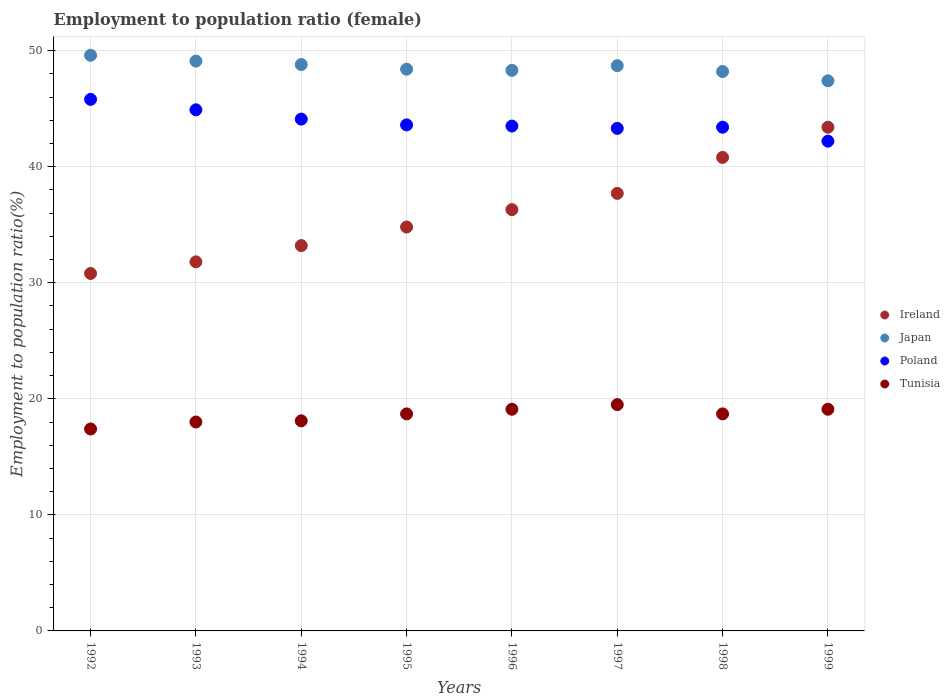How many different coloured dotlines are there?
Your answer should be very brief. 4. What is the employment to population ratio in Tunisia in 1994?
Your answer should be compact. 18.1. Across all years, what is the maximum employment to population ratio in Poland?
Make the answer very short. 45.8. Across all years, what is the minimum employment to population ratio in Tunisia?
Provide a short and direct response. 17.4. In which year was the employment to population ratio in Japan maximum?
Offer a terse response. 1992. What is the total employment to population ratio in Ireland in the graph?
Provide a short and direct response. 288.8. What is the difference between the employment to population ratio in Japan in 1996 and that in 1999?
Your answer should be very brief. 0.9. What is the difference between the employment to population ratio in Ireland in 1993 and the employment to population ratio in Poland in 1995?
Your response must be concise. -11.8. What is the average employment to population ratio in Tunisia per year?
Your answer should be very brief. 18.58. In the year 1997, what is the difference between the employment to population ratio in Tunisia and employment to population ratio in Japan?
Ensure brevity in your answer.  -29.2. In how many years, is the employment to population ratio in Ireland greater than 22 %?
Your response must be concise. 8. What is the ratio of the employment to population ratio in Japan in 1995 to that in 1999?
Your response must be concise. 1.02. What is the difference between the highest and the second highest employment to population ratio in Ireland?
Your response must be concise. 2.6. What is the difference between the highest and the lowest employment to population ratio in Ireland?
Your answer should be very brief. 12.6. Is the employment to population ratio in Japan strictly greater than the employment to population ratio in Poland over the years?
Offer a terse response. Yes. How many dotlines are there?
Provide a short and direct response. 4. How many years are there in the graph?
Your answer should be compact. 8. What is the difference between two consecutive major ticks on the Y-axis?
Keep it short and to the point. 10. Does the graph contain grids?
Make the answer very short. Yes. Where does the legend appear in the graph?
Offer a terse response. Center right. What is the title of the graph?
Offer a terse response. Employment to population ratio (female). Does "Venezuela" appear as one of the legend labels in the graph?
Provide a short and direct response. No. What is the Employment to population ratio(%) in Ireland in 1992?
Your answer should be compact. 30.8. What is the Employment to population ratio(%) in Japan in 1992?
Your answer should be very brief. 49.6. What is the Employment to population ratio(%) of Poland in 1992?
Your answer should be compact. 45.8. What is the Employment to population ratio(%) in Tunisia in 1992?
Give a very brief answer. 17.4. What is the Employment to population ratio(%) in Ireland in 1993?
Provide a succinct answer. 31.8. What is the Employment to population ratio(%) of Japan in 1993?
Your response must be concise. 49.1. What is the Employment to population ratio(%) in Poland in 1993?
Your answer should be compact. 44.9. What is the Employment to population ratio(%) in Ireland in 1994?
Your response must be concise. 33.2. What is the Employment to population ratio(%) in Japan in 1994?
Provide a short and direct response. 48.8. What is the Employment to population ratio(%) of Poland in 1994?
Provide a short and direct response. 44.1. What is the Employment to population ratio(%) in Tunisia in 1994?
Offer a terse response. 18.1. What is the Employment to population ratio(%) in Ireland in 1995?
Provide a short and direct response. 34.8. What is the Employment to population ratio(%) in Japan in 1995?
Offer a terse response. 48.4. What is the Employment to population ratio(%) of Poland in 1995?
Offer a very short reply. 43.6. What is the Employment to population ratio(%) in Tunisia in 1995?
Ensure brevity in your answer.  18.7. What is the Employment to population ratio(%) in Ireland in 1996?
Offer a terse response. 36.3. What is the Employment to population ratio(%) of Japan in 1996?
Your response must be concise. 48.3. What is the Employment to population ratio(%) in Poland in 1996?
Give a very brief answer. 43.5. What is the Employment to population ratio(%) of Tunisia in 1996?
Give a very brief answer. 19.1. What is the Employment to population ratio(%) of Ireland in 1997?
Give a very brief answer. 37.7. What is the Employment to population ratio(%) of Japan in 1997?
Ensure brevity in your answer.  48.7. What is the Employment to population ratio(%) in Poland in 1997?
Give a very brief answer. 43.3. What is the Employment to population ratio(%) in Tunisia in 1997?
Offer a very short reply. 19.5. What is the Employment to population ratio(%) of Ireland in 1998?
Your answer should be compact. 40.8. What is the Employment to population ratio(%) of Japan in 1998?
Provide a short and direct response. 48.2. What is the Employment to population ratio(%) in Poland in 1998?
Give a very brief answer. 43.4. What is the Employment to population ratio(%) in Tunisia in 1998?
Ensure brevity in your answer.  18.7. What is the Employment to population ratio(%) of Ireland in 1999?
Offer a very short reply. 43.4. What is the Employment to population ratio(%) of Japan in 1999?
Provide a succinct answer. 47.4. What is the Employment to population ratio(%) of Poland in 1999?
Your answer should be compact. 42.2. What is the Employment to population ratio(%) of Tunisia in 1999?
Ensure brevity in your answer.  19.1. Across all years, what is the maximum Employment to population ratio(%) of Ireland?
Your answer should be very brief. 43.4. Across all years, what is the maximum Employment to population ratio(%) of Japan?
Provide a succinct answer. 49.6. Across all years, what is the maximum Employment to population ratio(%) of Poland?
Your answer should be very brief. 45.8. Across all years, what is the minimum Employment to population ratio(%) in Ireland?
Give a very brief answer. 30.8. Across all years, what is the minimum Employment to population ratio(%) in Japan?
Provide a short and direct response. 47.4. Across all years, what is the minimum Employment to population ratio(%) of Poland?
Keep it short and to the point. 42.2. Across all years, what is the minimum Employment to population ratio(%) in Tunisia?
Make the answer very short. 17.4. What is the total Employment to population ratio(%) of Ireland in the graph?
Offer a terse response. 288.8. What is the total Employment to population ratio(%) in Japan in the graph?
Make the answer very short. 388.5. What is the total Employment to population ratio(%) in Poland in the graph?
Make the answer very short. 350.8. What is the total Employment to population ratio(%) in Tunisia in the graph?
Your answer should be compact. 148.6. What is the difference between the Employment to population ratio(%) in Ireland in 1992 and that in 1993?
Offer a terse response. -1. What is the difference between the Employment to population ratio(%) in Japan in 1992 and that in 1993?
Your answer should be compact. 0.5. What is the difference between the Employment to population ratio(%) of Japan in 1992 and that in 1994?
Make the answer very short. 0.8. What is the difference between the Employment to population ratio(%) of Poland in 1992 and that in 1994?
Your answer should be very brief. 1.7. What is the difference between the Employment to population ratio(%) of Ireland in 1992 and that in 1995?
Give a very brief answer. -4. What is the difference between the Employment to population ratio(%) in Poland in 1992 and that in 1995?
Your answer should be compact. 2.2. What is the difference between the Employment to population ratio(%) in Ireland in 1992 and that in 1996?
Your answer should be compact. -5.5. What is the difference between the Employment to population ratio(%) of Ireland in 1992 and that in 1997?
Your response must be concise. -6.9. What is the difference between the Employment to population ratio(%) in Japan in 1992 and that in 1997?
Provide a succinct answer. 0.9. What is the difference between the Employment to population ratio(%) in Poland in 1992 and that in 1997?
Provide a short and direct response. 2.5. What is the difference between the Employment to population ratio(%) in Japan in 1992 and that in 1998?
Your answer should be compact. 1.4. What is the difference between the Employment to population ratio(%) in Poland in 1992 and that in 1998?
Make the answer very short. 2.4. What is the difference between the Employment to population ratio(%) in Tunisia in 1992 and that in 1998?
Make the answer very short. -1.3. What is the difference between the Employment to population ratio(%) of Poland in 1992 and that in 1999?
Keep it short and to the point. 3.6. What is the difference between the Employment to population ratio(%) of Tunisia in 1993 and that in 1994?
Your response must be concise. -0.1. What is the difference between the Employment to population ratio(%) of Ireland in 1993 and that in 1995?
Offer a very short reply. -3. What is the difference between the Employment to population ratio(%) of Tunisia in 1993 and that in 1995?
Your answer should be very brief. -0.7. What is the difference between the Employment to population ratio(%) of Ireland in 1993 and that in 1996?
Ensure brevity in your answer.  -4.5. What is the difference between the Employment to population ratio(%) in Japan in 1993 and that in 1997?
Offer a very short reply. 0.4. What is the difference between the Employment to population ratio(%) in Japan in 1993 and that in 1998?
Offer a terse response. 0.9. What is the difference between the Employment to population ratio(%) in Tunisia in 1993 and that in 1998?
Offer a terse response. -0.7. What is the difference between the Employment to population ratio(%) of Japan in 1993 and that in 1999?
Keep it short and to the point. 1.7. What is the difference between the Employment to population ratio(%) in Poland in 1993 and that in 1999?
Your answer should be compact. 2.7. What is the difference between the Employment to population ratio(%) in Japan in 1994 and that in 1995?
Your response must be concise. 0.4. What is the difference between the Employment to population ratio(%) in Tunisia in 1994 and that in 1995?
Offer a terse response. -0.6. What is the difference between the Employment to population ratio(%) of Ireland in 1994 and that in 1996?
Provide a succinct answer. -3.1. What is the difference between the Employment to population ratio(%) of Japan in 1994 and that in 1996?
Your answer should be compact. 0.5. What is the difference between the Employment to population ratio(%) in Poland in 1994 and that in 1996?
Your answer should be compact. 0.6. What is the difference between the Employment to population ratio(%) in Tunisia in 1994 and that in 1996?
Your response must be concise. -1. What is the difference between the Employment to population ratio(%) of Ireland in 1994 and that in 1997?
Provide a succinct answer. -4.5. What is the difference between the Employment to population ratio(%) in Japan in 1994 and that in 1997?
Make the answer very short. 0.1. What is the difference between the Employment to population ratio(%) in Tunisia in 1994 and that in 1997?
Provide a short and direct response. -1.4. What is the difference between the Employment to population ratio(%) in Poland in 1994 and that in 1998?
Ensure brevity in your answer.  0.7. What is the difference between the Employment to population ratio(%) in Poland in 1994 and that in 1999?
Your answer should be compact. 1.9. What is the difference between the Employment to population ratio(%) of Japan in 1995 and that in 1996?
Ensure brevity in your answer.  0.1. What is the difference between the Employment to population ratio(%) of Ireland in 1995 and that in 1997?
Your answer should be very brief. -2.9. What is the difference between the Employment to population ratio(%) of Poland in 1995 and that in 1997?
Ensure brevity in your answer.  0.3. What is the difference between the Employment to population ratio(%) in Japan in 1995 and that in 1998?
Provide a succinct answer. 0.2. What is the difference between the Employment to population ratio(%) of Japan in 1995 and that in 1999?
Keep it short and to the point. 1. What is the difference between the Employment to population ratio(%) in Poland in 1995 and that in 1999?
Offer a terse response. 1.4. What is the difference between the Employment to population ratio(%) in Tunisia in 1995 and that in 1999?
Provide a short and direct response. -0.4. What is the difference between the Employment to population ratio(%) of Tunisia in 1996 and that in 1997?
Provide a short and direct response. -0.4. What is the difference between the Employment to population ratio(%) in Ireland in 1996 and that in 1998?
Your response must be concise. -4.5. What is the difference between the Employment to population ratio(%) of Tunisia in 1996 and that in 1998?
Your response must be concise. 0.4. What is the difference between the Employment to population ratio(%) of Tunisia in 1996 and that in 1999?
Keep it short and to the point. 0. What is the difference between the Employment to population ratio(%) in Ireland in 1997 and that in 1998?
Ensure brevity in your answer.  -3.1. What is the difference between the Employment to population ratio(%) of Poland in 1997 and that in 1998?
Give a very brief answer. -0.1. What is the difference between the Employment to population ratio(%) in Ireland in 1997 and that in 1999?
Make the answer very short. -5.7. What is the difference between the Employment to population ratio(%) in Japan in 1997 and that in 1999?
Offer a very short reply. 1.3. What is the difference between the Employment to population ratio(%) of Ireland in 1998 and that in 1999?
Make the answer very short. -2.6. What is the difference between the Employment to population ratio(%) of Tunisia in 1998 and that in 1999?
Your response must be concise. -0.4. What is the difference between the Employment to population ratio(%) of Ireland in 1992 and the Employment to population ratio(%) of Japan in 1993?
Your response must be concise. -18.3. What is the difference between the Employment to population ratio(%) of Ireland in 1992 and the Employment to population ratio(%) of Poland in 1993?
Your answer should be compact. -14.1. What is the difference between the Employment to population ratio(%) of Ireland in 1992 and the Employment to population ratio(%) of Tunisia in 1993?
Your answer should be very brief. 12.8. What is the difference between the Employment to population ratio(%) in Japan in 1992 and the Employment to population ratio(%) in Poland in 1993?
Offer a terse response. 4.7. What is the difference between the Employment to population ratio(%) of Japan in 1992 and the Employment to population ratio(%) of Tunisia in 1993?
Provide a succinct answer. 31.6. What is the difference between the Employment to population ratio(%) of Poland in 1992 and the Employment to population ratio(%) of Tunisia in 1993?
Provide a succinct answer. 27.8. What is the difference between the Employment to population ratio(%) of Ireland in 1992 and the Employment to population ratio(%) of Japan in 1994?
Ensure brevity in your answer.  -18. What is the difference between the Employment to population ratio(%) in Japan in 1992 and the Employment to population ratio(%) in Poland in 1994?
Provide a short and direct response. 5.5. What is the difference between the Employment to population ratio(%) in Japan in 1992 and the Employment to population ratio(%) in Tunisia in 1994?
Give a very brief answer. 31.5. What is the difference between the Employment to population ratio(%) in Poland in 1992 and the Employment to population ratio(%) in Tunisia in 1994?
Offer a very short reply. 27.7. What is the difference between the Employment to population ratio(%) of Ireland in 1992 and the Employment to population ratio(%) of Japan in 1995?
Keep it short and to the point. -17.6. What is the difference between the Employment to population ratio(%) of Ireland in 1992 and the Employment to population ratio(%) of Poland in 1995?
Keep it short and to the point. -12.8. What is the difference between the Employment to population ratio(%) of Ireland in 1992 and the Employment to population ratio(%) of Tunisia in 1995?
Your answer should be compact. 12.1. What is the difference between the Employment to population ratio(%) in Japan in 1992 and the Employment to population ratio(%) in Tunisia in 1995?
Provide a short and direct response. 30.9. What is the difference between the Employment to population ratio(%) of Poland in 1992 and the Employment to population ratio(%) of Tunisia in 1995?
Offer a very short reply. 27.1. What is the difference between the Employment to population ratio(%) in Ireland in 1992 and the Employment to population ratio(%) in Japan in 1996?
Ensure brevity in your answer.  -17.5. What is the difference between the Employment to population ratio(%) in Ireland in 1992 and the Employment to population ratio(%) in Poland in 1996?
Ensure brevity in your answer.  -12.7. What is the difference between the Employment to population ratio(%) in Japan in 1992 and the Employment to population ratio(%) in Poland in 1996?
Keep it short and to the point. 6.1. What is the difference between the Employment to population ratio(%) of Japan in 1992 and the Employment to population ratio(%) of Tunisia in 1996?
Keep it short and to the point. 30.5. What is the difference between the Employment to population ratio(%) of Poland in 1992 and the Employment to population ratio(%) of Tunisia in 1996?
Provide a short and direct response. 26.7. What is the difference between the Employment to population ratio(%) in Ireland in 1992 and the Employment to population ratio(%) in Japan in 1997?
Your answer should be compact. -17.9. What is the difference between the Employment to population ratio(%) in Japan in 1992 and the Employment to population ratio(%) in Tunisia in 1997?
Make the answer very short. 30.1. What is the difference between the Employment to population ratio(%) in Poland in 1992 and the Employment to population ratio(%) in Tunisia in 1997?
Your answer should be very brief. 26.3. What is the difference between the Employment to population ratio(%) in Ireland in 1992 and the Employment to population ratio(%) in Japan in 1998?
Ensure brevity in your answer.  -17.4. What is the difference between the Employment to population ratio(%) in Ireland in 1992 and the Employment to population ratio(%) in Tunisia in 1998?
Provide a short and direct response. 12.1. What is the difference between the Employment to population ratio(%) in Japan in 1992 and the Employment to population ratio(%) in Tunisia in 1998?
Offer a terse response. 30.9. What is the difference between the Employment to population ratio(%) of Poland in 1992 and the Employment to population ratio(%) of Tunisia in 1998?
Give a very brief answer. 27.1. What is the difference between the Employment to population ratio(%) of Ireland in 1992 and the Employment to population ratio(%) of Japan in 1999?
Your answer should be very brief. -16.6. What is the difference between the Employment to population ratio(%) of Japan in 1992 and the Employment to population ratio(%) of Poland in 1999?
Make the answer very short. 7.4. What is the difference between the Employment to population ratio(%) of Japan in 1992 and the Employment to population ratio(%) of Tunisia in 1999?
Offer a terse response. 30.5. What is the difference between the Employment to population ratio(%) of Poland in 1992 and the Employment to population ratio(%) of Tunisia in 1999?
Your answer should be very brief. 26.7. What is the difference between the Employment to population ratio(%) of Ireland in 1993 and the Employment to population ratio(%) of Japan in 1994?
Make the answer very short. -17. What is the difference between the Employment to population ratio(%) of Ireland in 1993 and the Employment to population ratio(%) of Poland in 1994?
Keep it short and to the point. -12.3. What is the difference between the Employment to population ratio(%) in Ireland in 1993 and the Employment to population ratio(%) in Tunisia in 1994?
Keep it short and to the point. 13.7. What is the difference between the Employment to population ratio(%) in Japan in 1993 and the Employment to population ratio(%) in Tunisia in 1994?
Your response must be concise. 31. What is the difference between the Employment to population ratio(%) of Poland in 1993 and the Employment to population ratio(%) of Tunisia in 1994?
Offer a very short reply. 26.8. What is the difference between the Employment to population ratio(%) in Ireland in 1993 and the Employment to population ratio(%) in Japan in 1995?
Your answer should be compact. -16.6. What is the difference between the Employment to population ratio(%) of Japan in 1993 and the Employment to population ratio(%) of Poland in 1995?
Keep it short and to the point. 5.5. What is the difference between the Employment to population ratio(%) of Japan in 1993 and the Employment to population ratio(%) of Tunisia in 1995?
Offer a terse response. 30.4. What is the difference between the Employment to population ratio(%) in Poland in 1993 and the Employment to population ratio(%) in Tunisia in 1995?
Offer a very short reply. 26.2. What is the difference between the Employment to population ratio(%) of Ireland in 1993 and the Employment to population ratio(%) of Japan in 1996?
Ensure brevity in your answer.  -16.5. What is the difference between the Employment to population ratio(%) of Ireland in 1993 and the Employment to population ratio(%) of Poland in 1996?
Keep it short and to the point. -11.7. What is the difference between the Employment to population ratio(%) of Japan in 1993 and the Employment to population ratio(%) of Tunisia in 1996?
Make the answer very short. 30. What is the difference between the Employment to population ratio(%) of Poland in 1993 and the Employment to population ratio(%) of Tunisia in 1996?
Offer a terse response. 25.8. What is the difference between the Employment to population ratio(%) of Ireland in 1993 and the Employment to population ratio(%) of Japan in 1997?
Your response must be concise. -16.9. What is the difference between the Employment to population ratio(%) of Ireland in 1993 and the Employment to population ratio(%) of Tunisia in 1997?
Give a very brief answer. 12.3. What is the difference between the Employment to population ratio(%) of Japan in 1993 and the Employment to population ratio(%) of Tunisia in 1997?
Your response must be concise. 29.6. What is the difference between the Employment to population ratio(%) in Poland in 1993 and the Employment to population ratio(%) in Tunisia in 1997?
Your answer should be very brief. 25.4. What is the difference between the Employment to population ratio(%) in Ireland in 1993 and the Employment to population ratio(%) in Japan in 1998?
Offer a very short reply. -16.4. What is the difference between the Employment to population ratio(%) in Ireland in 1993 and the Employment to population ratio(%) in Tunisia in 1998?
Your response must be concise. 13.1. What is the difference between the Employment to population ratio(%) of Japan in 1993 and the Employment to population ratio(%) of Poland in 1998?
Your answer should be compact. 5.7. What is the difference between the Employment to population ratio(%) of Japan in 1993 and the Employment to population ratio(%) of Tunisia in 1998?
Provide a succinct answer. 30.4. What is the difference between the Employment to population ratio(%) of Poland in 1993 and the Employment to population ratio(%) of Tunisia in 1998?
Ensure brevity in your answer.  26.2. What is the difference between the Employment to population ratio(%) of Ireland in 1993 and the Employment to population ratio(%) of Japan in 1999?
Provide a short and direct response. -15.6. What is the difference between the Employment to population ratio(%) in Japan in 1993 and the Employment to population ratio(%) in Tunisia in 1999?
Your response must be concise. 30. What is the difference between the Employment to population ratio(%) in Poland in 1993 and the Employment to population ratio(%) in Tunisia in 1999?
Provide a short and direct response. 25.8. What is the difference between the Employment to population ratio(%) of Ireland in 1994 and the Employment to population ratio(%) of Japan in 1995?
Your answer should be very brief. -15.2. What is the difference between the Employment to population ratio(%) of Ireland in 1994 and the Employment to population ratio(%) of Poland in 1995?
Give a very brief answer. -10.4. What is the difference between the Employment to population ratio(%) of Japan in 1994 and the Employment to population ratio(%) of Tunisia in 1995?
Your answer should be compact. 30.1. What is the difference between the Employment to population ratio(%) in Poland in 1994 and the Employment to population ratio(%) in Tunisia in 1995?
Your answer should be compact. 25.4. What is the difference between the Employment to population ratio(%) in Ireland in 1994 and the Employment to population ratio(%) in Japan in 1996?
Make the answer very short. -15.1. What is the difference between the Employment to population ratio(%) in Ireland in 1994 and the Employment to population ratio(%) in Poland in 1996?
Keep it short and to the point. -10.3. What is the difference between the Employment to population ratio(%) in Ireland in 1994 and the Employment to population ratio(%) in Tunisia in 1996?
Offer a very short reply. 14.1. What is the difference between the Employment to population ratio(%) of Japan in 1994 and the Employment to population ratio(%) of Poland in 1996?
Your answer should be compact. 5.3. What is the difference between the Employment to population ratio(%) in Japan in 1994 and the Employment to population ratio(%) in Tunisia in 1996?
Keep it short and to the point. 29.7. What is the difference between the Employment to population ratio(%) in Poland in 1994 and the Employment to population ratio(%) in Tunisia in 1996?
Make the answer very short. 25. What is the difference between the Employment to population ratio(%) in Ireland in 1994 and the Employment to population ratio(%) in Japan in 1997?
Give a very brief answer. -15.5. What is the difference between the Employment to population ratio(%) in Ireland in 1994 and the Employment to population ratio(%) in Tunisia in 1997?
Your answer should be very brief. 13.7. What is the difference between the Employment to population ratio(%) in Japan in 1994 and the Employment to population ratio(%) in Poland in 1997?
Ensure brevity in your answer.  5.5. What is the difference between the Employment to population ratio(%) of Japan in 1994 and the Employment to population ratio(%) of Tunisia in 1997?
Ensure brevity in your answer.  29.3. What is the difference between the Employment to population ratio(%) in Poland in 1994 and the Employment to population ratio(%) in Tunisia in 1997?
Provide a succinct answer. 24.6. What is the difference between the Employment to population ratio(%) of Japan in 1994 and the Employment to population ratio(%) of Tunisia in 1998?
Ensure brevity in your answer.  30.1. What is the difference between the Employment to population ratio(%) of Poland in 1994 and the Employment to population ratio(%) of Tunisia in 1998?
Give a very brief answer. 25.4. What is the difference between the Employment to population ratio(%) in Ireland in 1994 and the Employment to population ratio(%) in Japan in 1999?
Offer a terse response. -14.2. What is the difference between the Employment to population ratio(%) in Ireland in 1994 and the Employment to population ratio(%) in Tunisia in 1999?
Keep it short and to the point. 14.1. What is the difference between the Employment to population ratio(%) in Japan in 1994 and the Employment to population ratio(%) in Tunisia in 1999?
Your answer should be compact. 29.7. What is the difference between the Employment to population ratio(%) in Poland in 1994 and the Employment to population ratio(%) in Tunisia in 1999?
Keep it short and to the point. 25. What is the difference between the Employment to population ratio(%) of Japan in 1995 and the Employment to population ratio(%) of Tunisia in 1996?
Keep it short and to the point. 29.3. What is the difference between the Employment to population ratio(%) of Poland in 1995 and the Employment to population ratio(%) of Tunisia in 1996?
Make the answer very short. 24.5. What is the difference between the Employment to population ratio(%) in Ireland in 1995 and the Employment to population ratio(%) in Japan in 1997?
Give a very brief answer. -13.9. What is the difference between the Employment to population ratio(%) in Ireland in 1995 and the Employment to population ratio(%) in Poland in 1997?
Your answer should be compact. -8.5. What is the difference between the Employment to population ratio(%) in Ireland in 1995 and the Employment to population ratio(%) in Tunisia in 1997?
Offer a terse response. 15.3. What is the difference between the Employment to population ratio(%) of Japan in 1995 and the Employment to population ratio(%) of Tunisia in 1997?
Provide a succinct answer. 28.9. What is the difference between the Employment to population ratio(%) in Poland in 1995 and the Employment to population ratio(%) in Tunisia in 1997?
Provide a succinct answer. 24.1. What is the difference between the Employment to population ratio(%) of Ireland in 1995 and the Employment to population ratio(%) of Japan in 1998?
Your response must be concise. -13.4. What is the difference between the Employment to population ratio(%) of Japan in 1995 and the Employment to population ratio(%) of Tunisia in 1998?
Provide a succinct answer. 29.7. What is the difference between the Employment to population ratio(%) of Poland in 1995 and the Employment to population ratio(%) of Tunisia in 1998?
Make the answer very short. 24.9. What is the difference between the Employment to population ratio(%) of Japan in 1995 and the Employment to population ratio(%) of Poland in 1999?
Give a very brief answer. 6.2. What is the difference between the Employment to population ratio(%) of Japan in 1995 and the Employment to population ratio(%) of Tunisia in 1999?
Your answer should be very brief. 29.3. What is the difference between the Employment to population ratio(%) of Ireland in 1996 and the Employment to population ratio(%) of Japan in 1997?
Offer a terse response. -12.4. What is the difference between the Employment to population ratio(%) of Ireland in 1996 and the Employment to population ratio(%) of Poland in 1997?
Your response must be concise. -7. What is the difference between the Employment to population ratio(%) of Ireland in 1996 and the Employment to population ratio(%) of Tunisia in 1997?
Make the answer very short. 16.8. What is the difference between the Employment to population ratio(%) of Japan in 1996 and the Employment to population ratio(%) of Tunisia in 1997?
Your response must be concise. 28.8. What is the difference between the Employment to population ratio(%) of Ireland in 1996 and the Employment to population ratio(%) of Poland in 1998?
Provide a succinct answer. -7.1. What is the difference between the Employment to population ratio(%) in Japan in 1996 and the Employment to population ratio(%) in Poland in 1998?
Your answer should be compact. 4.9. What is the difference between the Employment to population ratio(%) in Japan in 1996 and the Employment to population ratio(%) in Tunisia in 1998?
Offer a terse response. 29.6. What is the difference between the Employment to population ratio(%) in Poland in 1996 and the Employment to population ratio(%) in Tunisia in 1998?
Provide a succinct answer. 24.8. What is the difference between the Employment to population ratio(%) in Ireland in 1996 and the Employment to population ratio(%) in Tunisia in 1999?
Your response must be concise. 17.2. What is the difference between the Employment to population ratio(%) in Japan in 1996 and the Employment to population ratio(%) in Poland in 1999?
Your answer should be compact. 6.1. What is the difference between the Employment to population ratio(%) of Japan in 1996 and the Employment to population ratio(%) of Tunisia in 1999?
Your answer should be very brief. 29.2. What is the difference between the Employment to population ratio(%) of Poland in 1996 and the Employment to population ratio(%) of Tunisia in 1999?
Make the answer very short. 24.4. What is the difference between the Employment to population ratio(%) of Ireland in 1997 and the Employment to population ratio(%) of Poland in 1998?
Make the answer very short. -5.7. What is the difference between the Employment to population ratio(%) in Japan in 1997 and the Employment to population ratio(%) in Tunisia in 1998?
Your answer should be very brief. 30. What is the difference between the Employment to population ratio(%) in Poland in 1997 and the Employment to population ratio(%) in Tunisia in 1998?
Provide a short and direct response. 24.6. What is the difference between the Employment to population ratio(%) in Japan in 1997 and the Employment to population ratio(%) in Poland in 1999?
Ensure brevity in your answer.  6.5. What is the difference between the Employment to population ratio(%) in Japan in 1997 and the Employment to population ratio(%) in Tunisia in 1999?
Give a very brief answer. 29.6. What is the difference between the Employment to population ratio(%) in Poland in 1997 and the Employment to population ratio(%) in Tunisia in 1999?
Provide a short and direct response. 24.2. What is the difference between the Employment to population ratio(%) in Ireland in 1998 and the Employment to population ratio(%) in Japan in 1999?
Keep it short and to the point. -6.6. What is the difference between the Employment to population ratio(%) in Ireland in 1998 and the Employment to population ratio(%) in Tunisia in 1999?
Give a very brief answer. 21.7. What is the difference between the Employment to population ratio(%) of Japan in 1998 and the Employment to population ratio(%) of Tunisia in 1999?
Offer a very short reply. 29.1. What is the difference between the Employment to population ratio(%) of Poland in 1998 and the Employment to population ratio(%) of Tunisia in 1999?
Keep it short and to the point. 24.3. What is the average Employment to population ratio(%) of Ireland per year?
Keep it short and to the point. 36.1. What is the average Employment to population ratio(%) of Japan per year?
Ensure brevity in your answer.  48.56. What is the average Employment to population ratio(%) in Poland per year?
Give a very brief answer. 43.85. What is the average Employment to population ratio(%) of Tunisia per year?
Ensure brevity in your answer.  18.57. In the year 1992, what is the difference between the Employment to population ratio(%) of Ireland and Employment to population ratio(%) of Japan?
Give a very brief answer. -18.8. In the year 1992, what is the difference between the Employment to population ratio(%) of Ireland and Employment to population ratio(%) of Poland?
Offer a very short reply. -15. In the year 1992, what is the difference between the Employment to population ratio(%) in Japan and Employment to population ratio(%) in Tunisia?
Your response must be concise. 32.2. In the year 1992, what is the difference between the Employment to population ratio(%) in Poland and Employment to population ratio(%) in Tunisia?
Offer a terse response. 28.4. In the year 1993, what is the difference between the Employment to population ratio(%) of Ireland and Employment to population ratio(%) of Japan?
Give a very brief answer. -17.3. In the year 1993, what is the difference between the Employment to population ratio(%) of Ireland and Employment to population ratio(%) of Poland?
Give a very brief answer. -13.1. In the year 1993, what is the difference between the Employment to population ratio(%) in Ireland and Employment to population ratio(%) in Tunisia?
Your answer should be compact. 13.8. In the year 1993, what is the difference between the Employment to population ratio(%) of Japan and Employment to population ratio(%) of Tunisia?
Your answer should be very brief. 31.1. In the year 1993, what is the difference between the Employment to population ratio(%) in Poland and Employment to population ratio(%) in Tunisia?
Make the answer very short. 26.9. In the year 1994, what is the difference between the Employment to population ratio(%) in Ireland and Employment to population ratio(%) in Japan?
Make the answer very short. -15.6. In the year 1994, what is the difference between the Employment to population ratio(%) in Ireland and Employment to population ratio(%) in Poland?
Provide a succinct answer. -10.9. In the year 1994, what is the difference between the Employment to population ratio(%) of Japan and Employment to population ratio(%) of Poland?
Provide a short and direct response. 4.7. In the year 1994, what is the difference between the Employment to population ratio(%) in Japan and Employment to population ratio(%) in Tunisia?
Your answer should be compact. 30.7. In the year 1994, what is the difference between the Employment to population ratio(%) of Poland and Employment to population ratio(%) of Tunisia?
Your response must be concise. 26. In the year 1995, what is the difference between the Employment to population ratio(%) in Japan and Employment to population ratio(%) in Tunisia?
Your answer should be very brief. 29.7. In the year 1995, what is the difference between the Employment to population ratio(%) of Poland and Employment to population ratio(%) of Tunisia?
Keep it short and to the point. 24.9. In the year 1996, what is the difference between the Employment to population ratio(%) in Ireland and Employment to population ratio(%) in Japan?
Provide a succinct answer. -12. In the year 1996, what is the difference between the Employment to population ratio(%) of Japan and Employment to population ratio(%) of Poland?
Provide a succinct answer. 4.8. In the year 1996, what is the difference between the Employment to population ratio(%) of Japan and Employment to population ratio(%) of Tunisia?
Your answer should be compact. 29.2. In the year 1996, what is the difference between the Employment to population ratio(%) of Poland and Employment to population ratio(%) of Tunisia?
Provide a succinct answer. 24.4. In the year 1997, what is the difference between the Employment to population ratio(%) of Ireland and Employment to population ratio(%) of Poland?
Provide a short and direct response. -5.6. In the year 1997, what is the difference between the Employment to population ratio(%) of Ireland and Employment to population ratio(%) of Tunisia?
Provide a short and direct response. 18.2. In the year 1997, what is the difference between the Employment to population ratio(%) of Japan and Employment to population ratio(%) of Poland?
Offer a very short reply. 5.4. In the year 1997, what is the difference between the Employment to population ratio(%) of Japan and Employment to population ratio(%) of Tunisia?
Offer a terse response. 29.2. In the year 1997, what is the difference between the Employment to population ratio(%) in Poland and Employment to population ratio(%) in Tunisia?
Ensure brevity in your answer.  23.8. In the year 1998, what is the difference between the Employment to population ratio(%) of Ireland and Employment to population ratio(%) of Poland?
Ensure brevity in your answer.  -2.6. In the year 1998, what is the difference between the Employment to population ratio(%) in Ireland and Employment to population ratio(%) in Tunisia?
Provide a short and direct response. 22.1. In the year 1998, what is the difference between the Employment to population ratio(%) in Japan and Employment to population ratio(%) in Tunisia?
Your answer should be compact. 29.5. In the year 1998, what is the difference between the Employment to population ratio(%) of Poland and Employment to population ratio(%) of Tunisia?
Make the answer very short. 24.7. In the year 1999, what is the difference between the Employment to population ratio(%) in Ireland and Employment to population ratio(%) in Tunisia?
Your response must be concise. 24.3. In the year 1999, what is the difference between the Employment to population ratio(%) in Japan and Employment to population ratio(%) in Tunisia?
Keep it short and to the point. 28.3. In the year 1999, what is the difference between the Employment to population ratio(%) of Poland and Employment to population ratio(%) of Tunisia?
Offer a very short reply. 23.1. What is the ratio of the Employment to population ratio(%) in Ireland in 1992 to that in 1993?
Your answer should be compact. 0.97. What is the ratio of the Employment to population ratio(%) in Japan in 1992 to that in 1993?
Give a very brief answer. 1.01. What is the ratio of the Employment to population ratio(%) in Poland in 1992 to that in 1993?
Keep it short and to the point. 1.02. What is the ratio of the Employment to population ratio(%) in Tunisia in 1992 to that in 1993?
Offer a very short reply. 0.97. What is the ratio of the Employment to population ratio(%) in Ireland in 1992 to that in 1994?
Provide a short and direct response. 0.93. What is the ratio of the Employment to population ratio(%) in Japan in 1992 to that in 1994?
Your response must be concise. 1.02. What is the ratio of the Employment to population ratio(%) of Tunisia in 1992 to that in 1994?
Provide a succinct answer. 0.96. What is the ratio of the Employment to population ratio(%) of Ireland in 1992 to that in 1995?
Your answer should be compact. 0.89. What is the ratio of the Employment to population ratio(%) in Japan in 1992 to that in 1995?
Offer a terse response. 1.02. What is the ratio of the Employment to population ratio(%) in Poland in 1992 to that in 1995?
Keep it short and to the point. 1.05. What is the ratio of the Employment to population ratio(%) of Tunisia in 1992 to that in 1995?
Give a very brief answer. 0.93. What is the ratio of the Employment to population ratio(%) in Ireland in 1992 to that in 1996?
Offer a very short reply. 0.85. What is the ratio of the Employment to population ratio(%) in Japan in 1992 to that in 1996?
Keep it short and to the point. 1.03. What is the ratio of the Employment to population ratio(%) of Poland in 1992 to that in 1996?
Provide a succinct answer. 1.05. What is the ratio of the Employment to population ratio(%) in Tunisia in 1992 to that in 1996?
Provide a short and direct response. 0.91. What is the ratio of the Employment to population ratio(%) in Ireland in 1992 to that in 1997?
Your answer should be compact. 0.82. What is the ratio of the Employment to population ratio(%) of Japan in 1992 to that in 1997?
Keep it short and to the point. 1.02. What is the ratio of the Employment to population ratio(%) in Poland in 1992 to that in 1997?
Give a very brief answer. 1.06. What is the ratio of the Employment to population ratio(%) of Tunisia in 1992 to that in 1997?
Ensure brevity in your answer.  0.89. What is the ratio of the Employment to population ratio(%) in Ireland in 1992 to that in 1998?
Your answer should be very brief. 0.75. What is the ratio of the Employment to population ratio(%) in Poland in 1992 to that in 1998?
Your answer should be compact. 1.06. What is the ratio of the Employment to population ratio(%) in Tunisia in 1992 to that in 1998?
Offer a very short reply. 0.93. What is the ratio of the Employment to population ratio(%) of Ireland in 1992 to that in 1999?
Give a very brief answer. 0.71. What is the ratio of the Employment to population ratio(%) in Japan in 1992 to that in 1999?
Provide a short and direct response. 1.05. What is the ratio of the Employment to population ratio(%) in Poland in 1992 to that in 1999?
Provide a short and direct response. 1.09. What is the ratio of the Employment to population ratio(%) of Tunisia in 1992 to that in 1999?
Provide a succinct answer. 0.91. What is the ratio of the Employment to population ratio(%) of Ireland in 1993 to that in 1994?
Keep it short and to the point. 0.96. What is the ratio of the Employment to population ratio(%) in Japan in 1993 to that in 1994?
Provide a short and direct response. 1.01. What is the ratio of the Employment to population ratio(%) of Poland in 1993 to that in 1994?
Offer a terse response. 1.02. What is the ratio of the Employment to population ratio(%) in Ireland in 1993 to that in 1995?
Keep it short and to the point. 0.91. What is the ratio of the Employment to population ratio(%) of Japan in 1993 to that in 1995?
Keep it short and to the point. 1.01. What is the ratio of the Employment to population ratio(%) of Poland in 1993 to that in 1995?
Keep it short and to the point. 1.03. What is the ratio of the Employment to population ratio(%) in Tunisia in 1993 to that in 1995?
Keep it short and to the point. 0.96. What is the ratio of the Employment to population ratio(%) of Ireland in 1993 to that in 1996?
Your answer should be very brief. 0.88. What is the ratio of the Employment to population ratio(%) of Japan in 1993 to that in 1996?
Offer a very short reply. 1.02. What is the ratio of the Employment to population ratio(%) in Poland in 1993 to that in 1996?
Keep it short and to the point. 1.03. What is the ratio of the Employment to population ratio(%) of Tunisia in 1993 to that in 1996?
Your answer should be very brief. 0.94. What is the ratio of the Employment to population ratio(%) in Ireland in 1993 to that in 1997?
Make the answer very short. 0.84. What is the ratio of the Employment to population ratio(%) in Japan in 1993 to that in 1997?
Your response must be concise. 1.01. What is the ratio of the Employment to population ratio(%) of Poland in 1993 to that in 1997?
Offer a very short reply. 1.04. What is the ratio of the Employment to population ratio(%) of Ireland in 1993 to that in 1998?
Ensure brevity in your answer.  0.78. What is the ratio of the Employment to population ratio(%) in Japan in 1993 to that in 1998?
Make the answer very short. 1.02. What is the ratio of the Employment to population ratio(%) of Poland in 1993 to that in 1998?
Offer a very short reply. 1.03. What is the ratio of the Employment to population ratio(%) of Tunisia in 1993 to that in 1998?
Your response must be concise. 0.96. What is the ratio of the Employment to population ratio(%) in Ireland in 1993 to that in 1999?
Your answer should be very brief. 0.73. What is the ratio of the Employment to population ratio(%) of Japan in 1993 to that in 1999?
Your response must be concise. 1.04. What is the ratio of the Employment to population ratio(%) of Poland in 1993 to that in 1999?
Offer a very short reply. 1.06. What is the ratio of the Employment to population ratio(%) in Tunisia in 1993 to that in 1999?
Offer a very short reply. 0.94. What is the ratio of the Employment to population ratio(%) in Ireland in 1994 to that in 1995?
Your answer should be very brief. 0.95. What is the ratio of the Employment to population ratio(%) in Japan in 1994 to that in 1995?
Your answer should be very brief. 1.01. What is the ratio of the Employment to population ratio(%) in Poland in 1994 to that in 1995?
Provide a succinct answer. 1.01. What is the ratio of the Employment to population ratio(%) in Tunisia in 1994 to that in 1995?
Provide a succinct answer. 0.97. What is the ratio of the Employment to population ratio(%) in Ireland in 1994 to that in 1996?
Your answer should be compact. 0.91. What is the ratio of the Employment to population ratio(%) of Japan in 1994 to that in 1996?
Offer a terse response. 1.01. What is the ratio of the Employment to population ratio(%) in Poland in 1994 to that in 1996?
Keep it short and to the point. 1.01. What is the ratio of the Employment to population ratio(%) of Tunisia in 1994 to that in 1996?
Keep it short and to the point. 0.95. What is the ratio of the Employment to population ratio(%) of Ireland in 1994 to that in 1997?
Provide a succinct answer. 0.88. What is the ratio of the Employment to population ratio(%) of Poland in 1994 to that in 1997?
Provide a short and direct response. 1.02. What is the ratio of the Employment to population ratio(%) of Tunisia in 1994 to that in 1997?
Provide a succinct answer. 0.93. What is the ratio of the Employment to population ratio(%) in Ireland in 1994 to that in 1998?
Make the answer very short. 0.81. What is the ratio of the Employment to population ratio(%) in Japan in 1994 to that in 1998?
Ensure brevity in your answer.  1.01. What is the ratio of the Employment to population ratio(%) of Poland in 1994 to that in 1998?
Offer a terse response. 1.02. What is the ratio of the Employment to population ratio(%) of Tunisia in 1994 to that in 1998?
Ensure brevity in your answer.  0.97. What is the ratio of the Employment to population ratio(%) in Ireland in 1994 to that in 1999?
Provide a short and direct response. 0.77. What is the ratio of the Employment to population ratio(%) of Japan in 1994 to that in 1999?
Provide a succinct answer. 1.03. What is the ratio of the Employment to population ratio(%) in Poland in 1994 to that in 1999?
Give a very brief answer. 1.04. What is the ratio of the Employment to population ratio(%) of Tunisia in 1994 to that in 1999?
Provide a succinct answer. 0.95. What is the ratio of the Employment to population ratio(%) of Ireland in 1995 to that in 1996?
Give a very brief answer. 0.96. What is the ratio of the Employment to population ratio(%) in Japan in 1995 to that in 1996?
Offer a terse response. 1. What is the ratio of the Employment to population ratio(%) in Poland in 1995 to that in 1996?
Your answer should be very brief. 1. What is the ratio of the Employment to population ratio(%) in Tunisia in 1995 to that in 1996?
Your answer should be compact. 0.98. What is the ratio of the Employment to population ratio(%) of Japan in 1995 to that in 1997?
Your answer should be compact. 0.99. What is the ratio of the Employment to population ratio(%) in Tunisia in 1995 to that in 1997?
Give a very brief answer. 0.96. What is the ratio of the Employment to population ratio(%) of Ireland in 1995 to that in 1998?
Keep it short and to the point. 0.85. What is the ratio of the Employment to population ratio(%) of Japan in 1995 to that in 1998?
Offer a terse response. 1. What is the ratio of the Employment to population ratio(%) of Ireland in 1995 to that in 1999?
Offer a terse response. 0.8. What is the ratio of the Employment to population ratio(%) in Japan in 1995 to that in 1999?
Your answer should be compact. 1.02. What is the ratio of the Employment to population ratio(%) in Poland in 1995 to that in 1999?
Give a very brief answer. 1.03. What is the ratio of the Employment to population ratio(%) in Tunisia in 1995 to that in 1999?
Your response must be concise. 0.98. What is the ratio of the Employment to population ratio(%) in Ireland in 1996 to that in 1997?
Provide a succinct answer. 0.96. What is the ratio of the Employment to population ratio(%) of Japan in 1996 to that in 1997?
Your answer should be very brief. 0.99. What is the ratio of the Employment to population ratio(%) in Tunisia in 1996 to that in 1997?
Ensure brevity in your answer.  0.98. What is the ratio of the Employment to population ratio(%) of Ireland in 1996 to that in 1998?
Provide a short and direct response. 0.89. What is the ratio of the Employment to population ratio(%) of Tunisia in 1996 to that in 1998?
Ensure brevity in your answer.  1.02. What is the ratio of the Employment to population ratio(%) of Ireland in 1996 to that in 1999?
Your answer should be compact. 0.84. What is the ratio of the Employment to population ratio(%) of Poland in 1996 to that in 1999?
Your answer should be very brief. 1.03. What is the ratio of the Employment to population ratio(%) in Tunisia in 1996 to that in 1999?
Provide a succinct answer. 1. What is the ratio of the Employment to population ratio(%) of Ireland in 1997 to that in 1998?
Give a very brief answer. 0.92. What is the ratio of the Employment to population ratio(%) of Japan in 1997 to that in 1998?
Give a very brief answer. 1.01. What is the ratio of the Employment to population ratio(%) of Poland in 1997 to that in 1998?
Provide a short and direct response. 1. What is the ratio of the Employment to population ratio(%) of Tunisia in 1997 to that in 1998?
Ensure brevity in your answer.  1.04. What is the ratio of the Employment to population ratio(%) of Ireland in 1997 to that in 1999?
Ensure brevity in your answer.  0.87. What is the ratio of the Employment to population ratio(%) of Japan in 1997 to that in 1999?
Provide a succinct answer. 1.03. What is the ratio of the Employment to population ratio(%) in Poland in 1997 to that in 1999?
Ensure brevity in your answer.  1.03. What is the ratio of the Employment to population ratio(%) in Tunisia in 1997 to that in 1999?
Provide a succinct answer. 1.02. What is the ratio of the Employment to population ratio(%) of Ireland in 1998 to that in 1999?
Offer a terse response. 0.94. What is the ratio of the Employment to population ratio(%) of Japan in 1998 to that in 1999?
Provide a succinct answer. 1.02. What is the ratio of the Employment to population ratio(%) in Poland in 1998 to that in 1999?
Offer a terse response. 1.03. What is the ratio of the Employment to population ratio(%) of Tunisia in 1998 to that in 1999?
Provide a succinct answer. 0.98. What is the difference between the highest and the second highest Employment to population ratio(%) of Ireland?
Your answer should be compact. 2.6. What is the difference between the highest and the second highest Employment to population ratio(%) in Japan?
Your response must be concise. 0.5. What is the difference between the highest and the second highest Employment to population ratio(%) of Poland?
Keep it short and to the point. 0.9. What is the difference between the highest and the second highest Employment to population ratio(%) of Tunisia?
Offer a terse response. 0.4. What is the difference between the highest and the lowest Employment to population ratio(%) in Tunisia?
Your response must be concise. 2.1. 